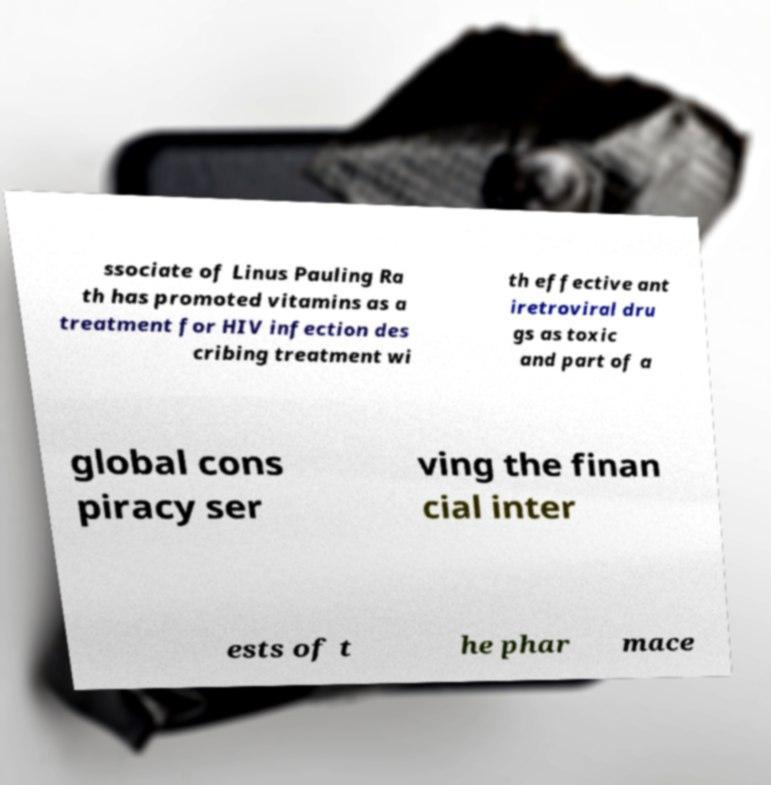Can you read and provide the text displayed in the image?This photo seems to have some interesting text. Can you extract and type it out for me? ssociate of Linus Pauling Ra th has promoted vitamins as a treatment for HIV infection des cribing treatment wi th effective ant iretroviral dru gs as toxic and part of a global cons piracy ser ving the finan cial inter ests of t he phar mace 